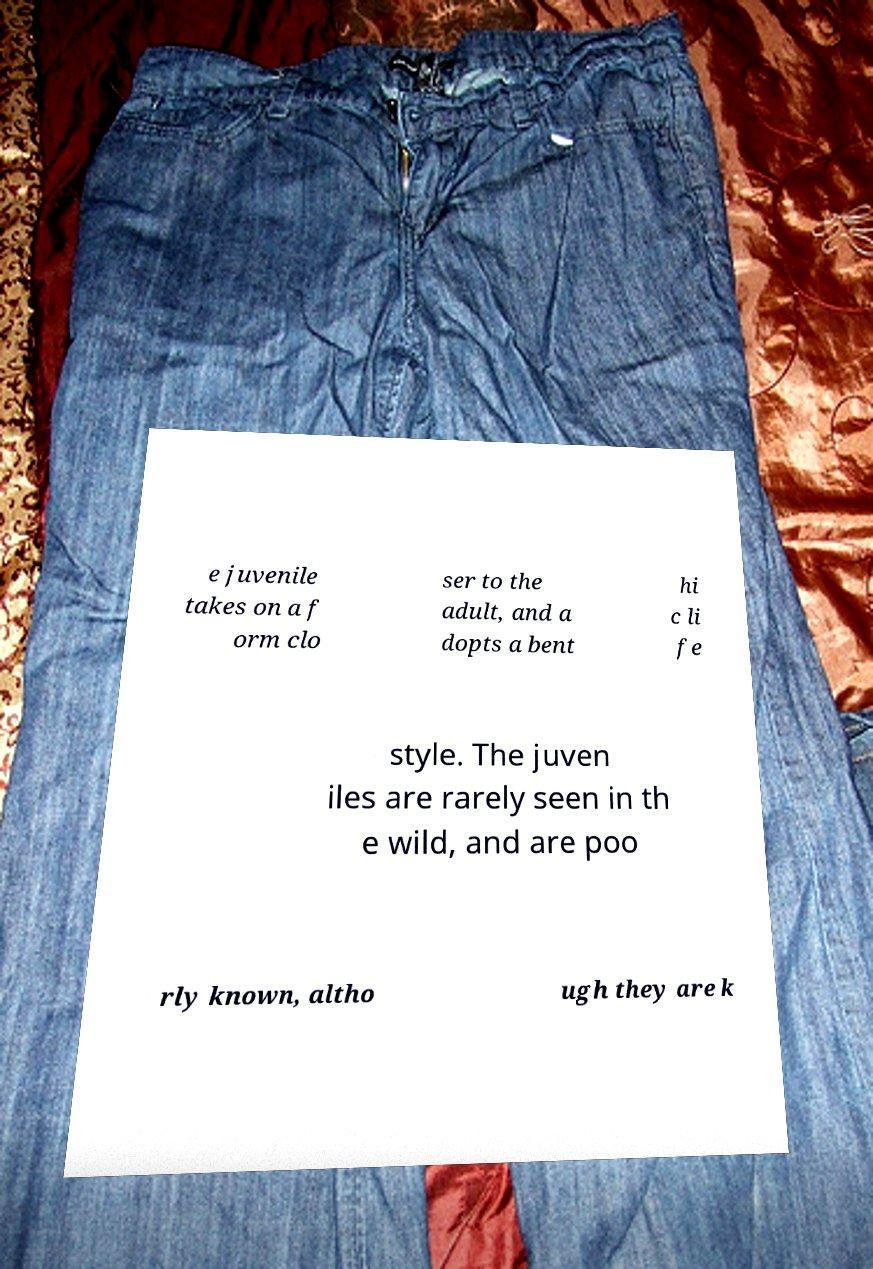Please read and relay the text visible in this image. What does it say? e juvenile takes on a f orm clo ser to the adult, and a dopts a bent hi c li fe style. The juven iles are rarely seen in th e wild, and are poo rly known, altho ugh they are k 